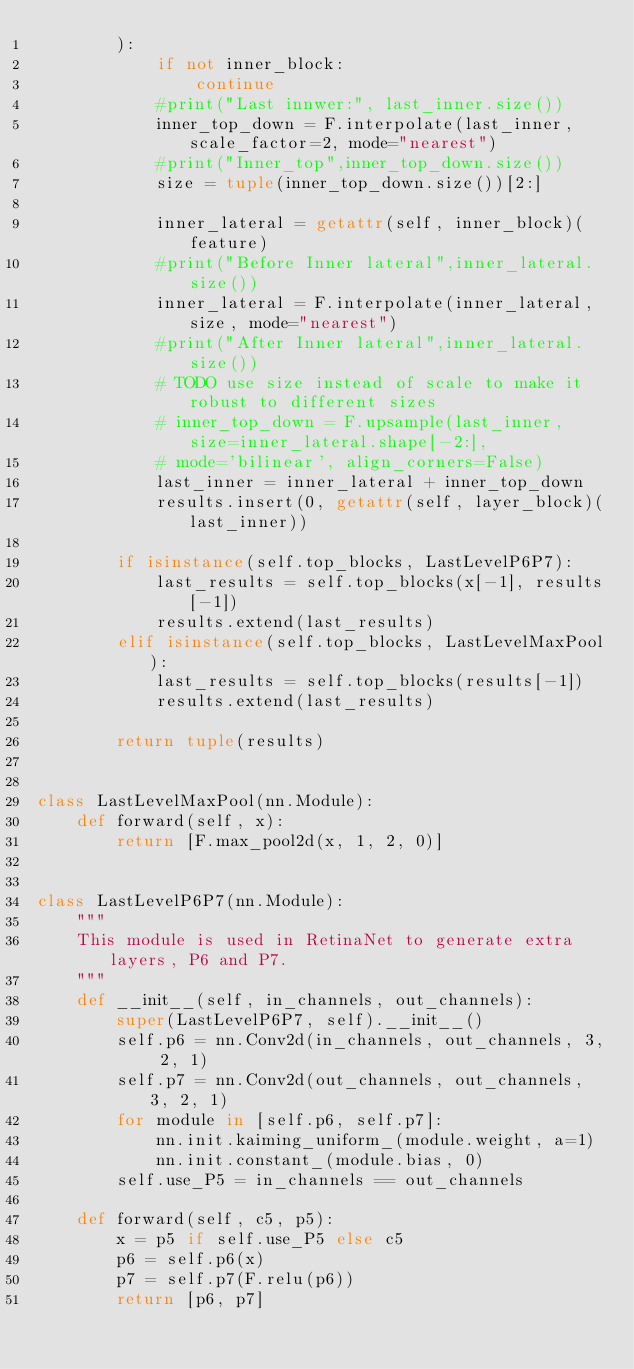<code> <loc_0><loc_0><loc_500><loc_500><_Python_>        ):
            if not inner_block:
                continue
            #print("Last innwer:", last_inner.size())
            inner_top_down = F.interpolate(last_inner, scale_factor=2, mode="nearest")
            #print("Inner_top",inner_top_down.size())
            size = tuple(inner_top_down.size())[2:]

            inner_lateral = getattr(self, inner_block)(feature)
            #print("Before Inner lateral",inner_lateral.size())
            inner_lateral = F.interpolate(inner_lateral,size, mode="nearest")
            #print("After Inner lateral",inner_lateral.size())
            # TODO use size instead of scale to make it robust to different sizes
            # inner_top_down = F.upsample(last_inner, size=inner_lateral.shape[-2:],
            # mode='bilinear', align_corners=False)
            last_inner = inner_lateral + inner_top_down
            results.insert(0, getattr(self, layer_block)(last_inner))

        if isinstance(self.top_blocks, LastLevelP6P7):
            last_results = self.top_blocks(x[-1], results[-1])
            results.extend(last_results)
        elif isinstance(self.top_blocks, LastLevelMaxPool):
            last_results = self.top_blocks(results[-1])
            results.extend(last_results)

        return tuple(results)


class LastLevelMaxPool(nn.Module):
    def forward(self, x):
        return [F.max_pool2d(x, 1, 2, 0)]


class LastLevelP6P7(nn.Module):
    """
    This module is used in RetinaNet to generate extra layers, P6 and P7.
    """
    def __init__(self, in_channels, out_channels):
        super(LastLevelP6P7, self).__init__()
        self.p6 = nn.Conv2d(in_channels, out_channels, 3, 2, 1)
        self.p7 = nn.Conv2d(out_channels, out_channels, 3, 2, 1)
        for module in [self.p6, self.p7]:
            nn.init.kaiming_uniform_(module.weight, a=1)
            nn.init.constant_(module.bias, 0)
        self.use_P5 = in_channels == out_channels

    def forward(self, c5, p5):
        x = p5 if self.use_P5 else c5
        p6 = self.p6(x)
        p7 = self.p7(F.relu(p6))
        return [p6, p7]
</code> 